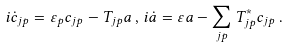<formula> <loc_0><loc_0><loc_500><loc_500>i \dot { c } _ { j p } = \varepsilon _ { p } c _ { j p } - T _ { j p } a \, , \, i \dot { a } = \varepsilon a - \sum _ { j p } T _ { j p } ^ { * } c _ { j p } \, .</formula> 